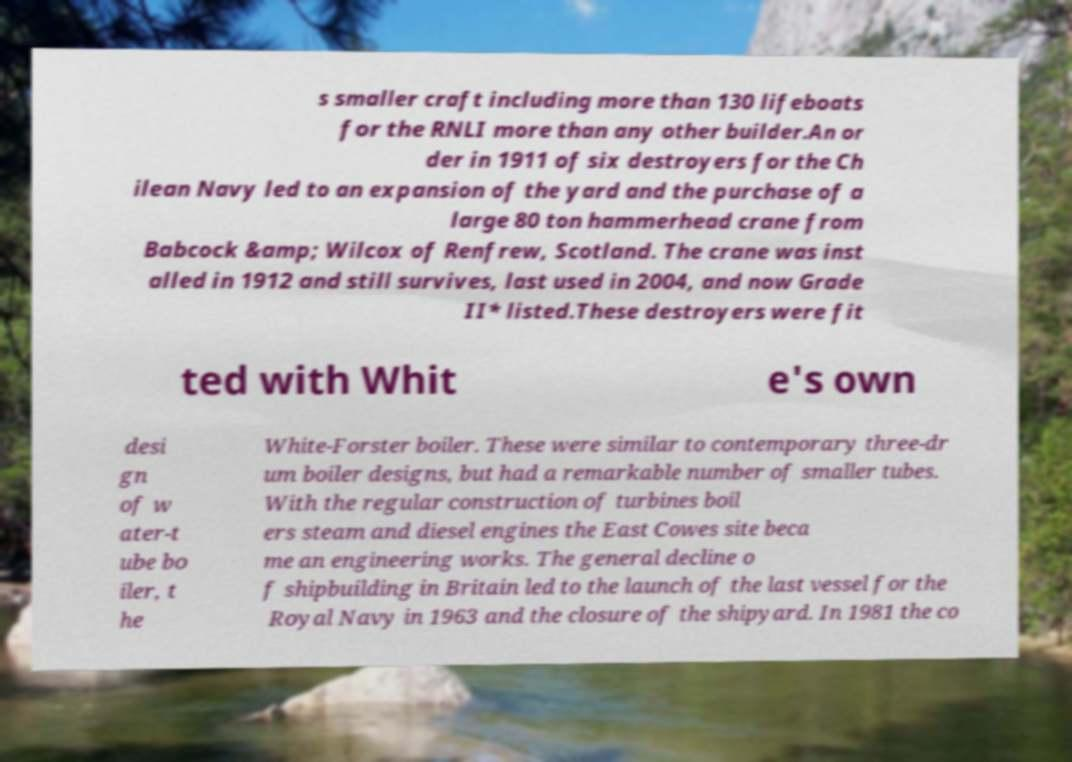There's text embedded in this image that I need extracted. Can you transcribe it verbatim? s smaller craft including more than 130 lifeboats for the RNLI more than any other builder.An or der in 1911 of six destroyers for the Ch ilean Navy led to an expansion of the yard and the purchase of a large 80 ton hammerhead crane from Babcock &amp; Wilcox of Renfrew, Scotland. The crane was inst alled in 1912 and still survives, last used in 2004, and now Grade II* listed.These destroyers were fit ted with Whit e's own desi gn of w ater-t ube bo iler, t he White-Forster boiler. These were similar to contemporary three-dr um boiler designs, but had a remarkable number of smaller tubes. With the regular construction of turbines boil ers steam and diesel engines the East Cowes site beca me an engineering works. The general decline o f shipbuilding in Britain led to the launch of the last vessel for the Royal Navy in 1963 and the closure of the shipyard. In 1981 the co 